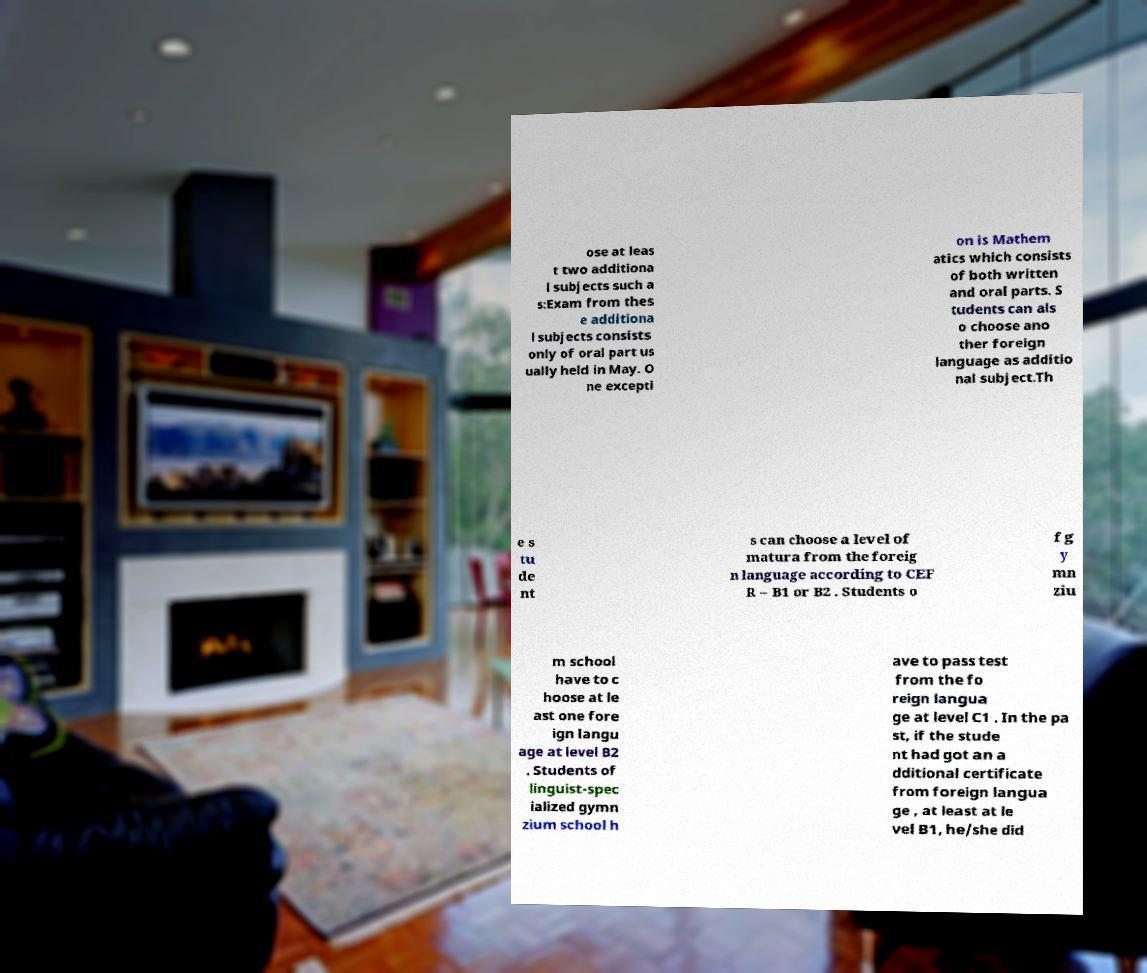Could you assist in decoding the text presented in this image and type it out clearly? ose at leas t two additiona l subjects such a s:Exam from thes e additiona l subjects consists only of oral part us ually held in May. O ne excepti on is Mathem atics which consists of both written and oral parts. S tudents can als o choose ano ther foreign language as additio nal subject.Th e s tu de nt s can choose a level of matura from the foreig n language according to CEF R – B1 or B2 . Students o f g y mn ziu m school have to c hoose at le ast one fore ign langu age at level B2 . Students of linguist-spec ialized gymn zium school h ave to pass test from the fo reign langua ge at level C1 . In the pa st, if the stude nt had got an a dditional certificate from foreign langua ge , at least at le vel B1, he/she did 